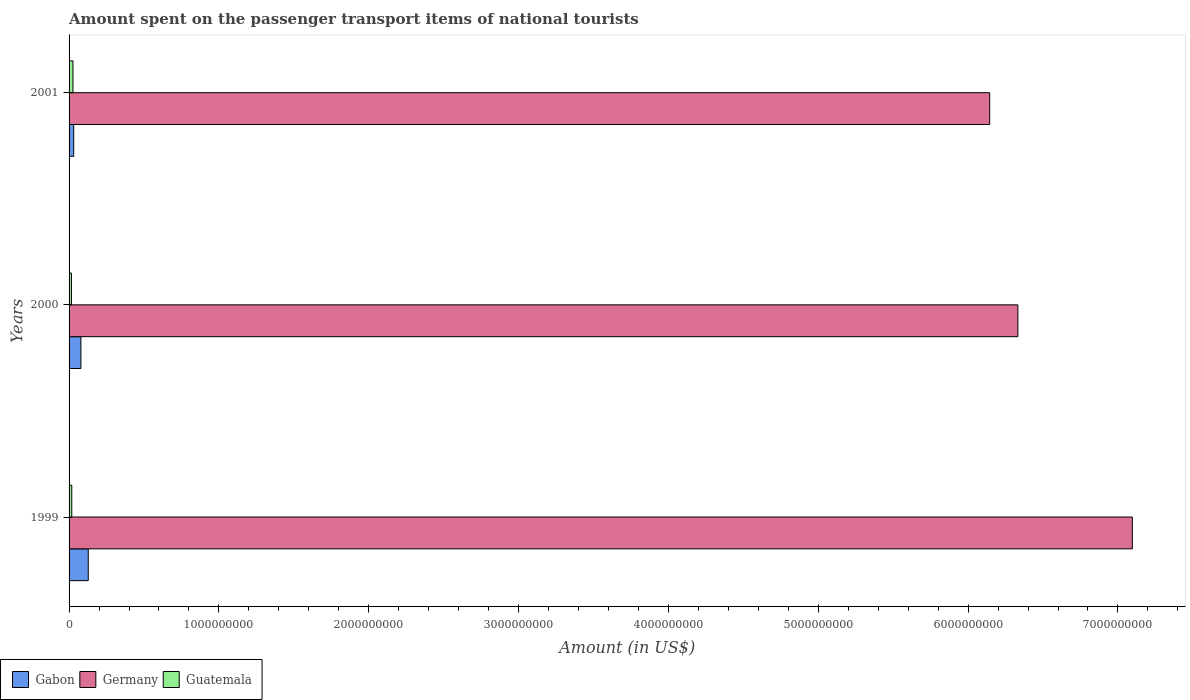How many different coloured bars are there?
Give a very brief answer. 3. How many bars are there on the 2nd tick from the top?
Provide a succinct answer. 3. What is the amount spent on the passenger transport items of national tourists in Guatemala in 2001?
Your answer should be compact. 2.60e+07. Across all years, what is the maximum amount spent on the passenger transport items of national tourists in Germany?
Give a very brief answer. 7.10e+09. Across all years, what is the minimum amount spent on the passenger transport items of national tourists in Germany?
Your response must be concise. 6.14e+09. In which year was the amount spent on the passenger transport items of national tourists in Guatemala minimum?
Offer a very short reply. 2000. What is the total amount spent on the passenger transport items of national tourists in Gabon in the graph?
Provide a short and direct response. 2.38e+08. What is the difference between the amount spent on the passenger transport items of national tourists in Germany in 2000 and that in 2001?
Your answer should be compact. 1.88e+08. What is the difference between the amount spent on the passenger transport items of national tourists in Gabon in 1999 and the amount spent on the passenger transport items of national tourists in Germany in 2001?
Provide a short and direct response. -6.02e+09. What is the average amount spent on the passenger transport items of national tourists in Gabon per year?
Keep it short and to the point. 7.93e+07. In the year 1999, what is the difference between the amount spent on the passenger transport items of national tourists in Gabon and amount spent on the passenger transport items of national tourists in Germany?
Give a very brief answer. -6.97e+09. In how many years, is the amount spent on the passenger transport items of national tourists in Guatemala greater than 600000000 US$?
Your response must be concise. 0. Is the difference between the amount spent on the passenger transport items of national tourists in Gabon in 2000 and 2001 greater than the difference between the amount spent on the passenger transport items of national tourists in Germany in 2000 and 2001?
Make the answer very short. No. What is the difference between the highest and the second highest amount spent on the passenger transport items of national tourists in Gabon?
Make the answer very short. 4.90e+07. What is the difference between the highest and the lowest amount spent on the passenger transport items of national tourists in Guatemala?
Offer a terse response. 1.00e+07. What does the 1st bar from the top in 2000 represents?
Keep it short and to the point. Guatemala. What does the 3rd bar from the bottom in 2000 represents?
Provide a succinct answer. Guatemala. Are all the bars in the graph horizontal?
Offer a very short reply. Yes. What is the difference between two consecutive major ticks on the X-axis?
Your answer should be compact. 1.00e+09. Where does the legend appear in the graph?
Offer a very short reply. Bottom left. How are the legend labels stacked?
Offer a terse response. Horizontal. What is the title of the graph?
Your answer should be very brief. Amount spent on the passenger transport items of national tourists. Does "Guinea" appear as one of the legend labels in the graph?
Offer a very short reply. No. What is the label or title of the X-axis?
Keep it short and to the point. Amount (in US$). What is the label or title of the Y-axis?
Provide a short and direct response. Years. What is the Amount (in US$) in Gabon in 1999?
Ensure brevity in your answer.  1.28e+08. What is the Amount (in US$) in Germany in 1999?
Give a very brief answer. 7.10e+09. What is the Amount (in US$) of Guatemala in 1999?
Make the answer very short. 1.80e+07. What is the Amount (in US$) of Gabon in 2000?
Offer a very short reply. 7.90e+07. What is the Amount (in US$) of Germany in 2000?
Ensure brevity in your answer.  6.33e+09. What is the Amount (in US$) in Guatemala in 2000?
Make the answer very short. 1.60e+07. What is the Amount (in US$) in Gabon in 2001?
Your answer should be very brief. 3.10e+07. What is the Amount (in US$) of Germany in 2001?
Provide a succinct answer. 6.14e+09. What is the Amount (in US$) of Guatemala in 2001?
Keep it short and to the point. 2.60e+07. Across all years, what is the maximum Amount (in US$) in Gabon?
Keep it short and to the point. 1.28e+08. Across all years, what is the maximum Amount (in US$) in Germany?
Provide a short and direct response. 7.10e+09. Across all years, what is the maximum Amount (in US$) in Guatemala?
Give a very brief answer. 2.60e+07. Across all years, what is the minimum Amount (in US$) in Gabon?
Offer a terse response. 3.10e+07. Across all years, what is the minimum Amount (in US$) in Germany?
Provide a succinct answer. 6.14e+09. Across all years, what is the minimum Amount (in US$) in Guatemala?
Give a very brief answer. 1.60e+07. What is the total Amount (in US$) of Gabon in the graph?
Make the answer very short. 2.38e+08. What is the total Amount (in US$) of Germany in the graph?
Offer a terse response. 1.96e+1. What is the total Amount (in US$) of Guatemala in the graph?
Offer a terse response. 6.00e+07. What is the difference between the Amount (in US$) in Gabon in 1999 and that in 2000?
Provide a short and direct response. 4.90e+07. What is the difference between the Amount (in US$) in Germany in 1999 and that in 2000?
Offer a terse response. 7.64e+08. What is the difference between the Amount (in US$) in Guatemala in 1999 and that in 2000?
Ensure brevity in your answer.  2.00e+06. What is the difference between the Amount (in US$) in Gabon in 1999 and that in 2001?
Provide a succinct answer. 9.70e+07. What is the difference between the Amount (in US$) in Germany in 1999 and that in 2001?
Your response must be concise. 9.52e+08. What is the difference between the Amount (in US$) in Guatemala in 1999 and that in 2001?
Keep it short and to the point. -8.00e+06. What is the difference between the Amount (in US$) of Gabon in 2000 and that in 2001?
Keep it short and to the point. 4.80e+07. What is the difference between the Amount (in US$) of Germany in 2000 and that in 2001?
Your answer should be very brief. 1.88e+08. What is the difference between the Amount (in US$) in Guatemala in 2000 and that in 2001?
Give a very brief answer. -1.00e+07. What is the difference between the Amount (in US$) in Gabon in 1999 and the Amount (in US$) in Germany in 2000?
Make the answer very short. -6.20e+09. What is the difference between the Amount (in US$) in Gabon in 1999 and the Amount (in US$) in Guatemala in 2000?
Make the answer very short. 1.12e+08. What is the difference between the Amount (in US$) of Germany in 1999 and the Amount (in US$) of Guatemala in 2000?
Ensure brevity in your answer.  7.08e+09. What is the difference between the Amount (in US$) of Gabon in 1999 and the Amount (in US$) of Germany in 2001?
Provide a succinct answer. -6.02e+09. What is the difference between the Amount (in US$) of Gabon in 1999 and the Amount (in US$) of Guatemala in 2001?
Keep it short and to the point. 1.02e+08. What is the difference between the Amount (in US$) in Germany in 1999 and the Amount (in US$) in Guatemala in 2001?
Your answer should be very brief. 7.07e+09. What is the difference between the Amount (in US$) in Gabon in 2000 and the Amount (in US$) in Germany in 2001?
Offer a terse response. -6.06e+09. What is the difference between the Amount (in US$) in Gabon in 2000 and the Amount (in US$) in Guatemala in 2001?
Your answer should be compact. 5.30e+07. What is the difference between the Amount (in US$) of Germany in 2000 and the Amount (in US$) of Guatemala in 2001?
Provide a short and direct response. 6.31e+09. What is the average Amount (in US$) of Gabon per year?
Your answer should be very brief. 7.93e+07. What is the average Amount (in US$) of Germany per year?
Offer a terse response. 6.52e+09. What is the average Amount (in US$) in Guatemala per year?
Offer a terse response. 2.00e+07. In the year 1999, what is the difference between the Amount (in US$) in Gabon and Amount (in US$) in Germany?
Make the answer very short. -6.97e+09. In the year 1999, what is the difference between the Amount (in US$) of Gabon and Amount (in US$) of Guatemala?
Your answer should be compact. 1.10e+08. In the year 1999, what is the difference between the Amount (in US$) of Germany and Amount (in US$) of Guatemala?
Offer a very short reply. 7.08e+09. In the year 2000, what is the difference between the Amount (in US$) in Gabon and Amount (in US$) in Germany?
Give a very brief answer. -6.25e+09. In the year 2000, what is the difference between the Amount (in US$) in Gabon and Amount (in US$) in Guatemala?
Provide a succinct answer. 6.30e+07. In the year 2000, what is the difference between the Amount (in US$) in Germany and Amount (in US$) in Guatemala?
Your answer should be very brief. 6.32e+09. In the year 2001, what is the difference between the Amount (in US$) of Gabon and Amount (in US$) of Germany?
Provide a succinct answer. -6.11e+09. In the year 2001, what is the difference between the Amount (in US$) of Germany and Amount (in US$) of Guatemala?
Keep it short and to the point. 6.12e+09. What is the ratio of the Amount (in US$) in Gabon in 1999 to that in 2000?
Ensure brevity in your answer.  1.62. What is the ratio of the Amount (in US$) in Germany in 1999 to that in 2000?
Offer a terse response. 1.12. What is the ratio of the Amount (in US$) in Gabon in 1999 to that in 2001?
Give a very brief answer. 4.13. What is the ratio of the Amount (in US$) in Germany in 1999 to that in 2001?
Give a very brief answer. 1.15. What is the ratio of the Amount (in US$) of Guatemala in 1999 to that in 2001?
Provide a short and direct response. 0.69. What is the ratio of the Amount (in US$) of Gabon in 2000 to that in 2001?
Make the answer very short. 2.55. What is the ratio of the Amount (in US$) of Germany in 2000 to that in 2001?
Offer a terse response. 1.03. What is the ratio of the Amount (in US$) in Guatemala in 2000 to that in 2001?
Provide a succinct answer. 0.62. What is the difference between the highest and the second highest Amount (in US$) of Gabon?
Provide a short and direct response. 4.90e+07. What is the difference between the highest and the second highest Amount (in US$) of Germany?
Offer a very short reply. 7.64e+08. What is the difference between the highest and the lowest Amount (in US$) of Gabon?
Offer a very short reply. 9.70e+07. What is the difference between the highest and the lowest Amount (in US$) of Germany?
Provide a succinct answer. 9.52e+08. What is the difference between the highest and the lowest Amount (in US$) in Guatemala?
Provide a short and direct response. 1.00e+07. 